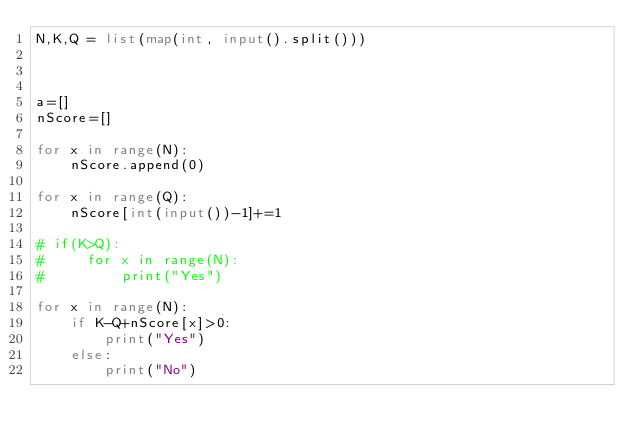Convert code to text. <code><loc_0><loc_0><loc_500><loc_500><_Python_>N,K,Q = list(map(int, input().split()))



a=[]
nScore=[]

for x in range(N):
    nScore.append(0)

for x in range(Q):
    nScore[int(input())-1]+=1

# if(K>Q):
#     for x in range(N):
#         print("Yes")

for x in range(N):
    if K-Q+nScore[x]>0:
        print("Yes")
    else:
        print("No")



</code> 